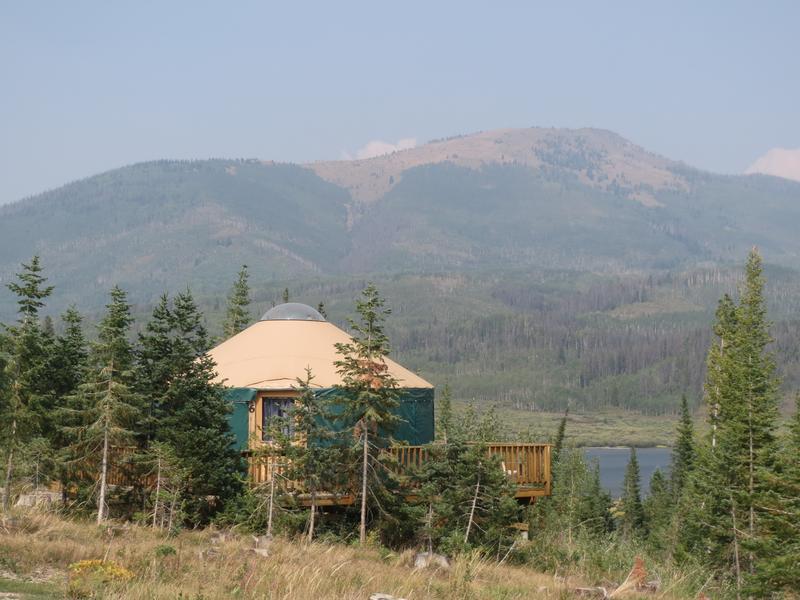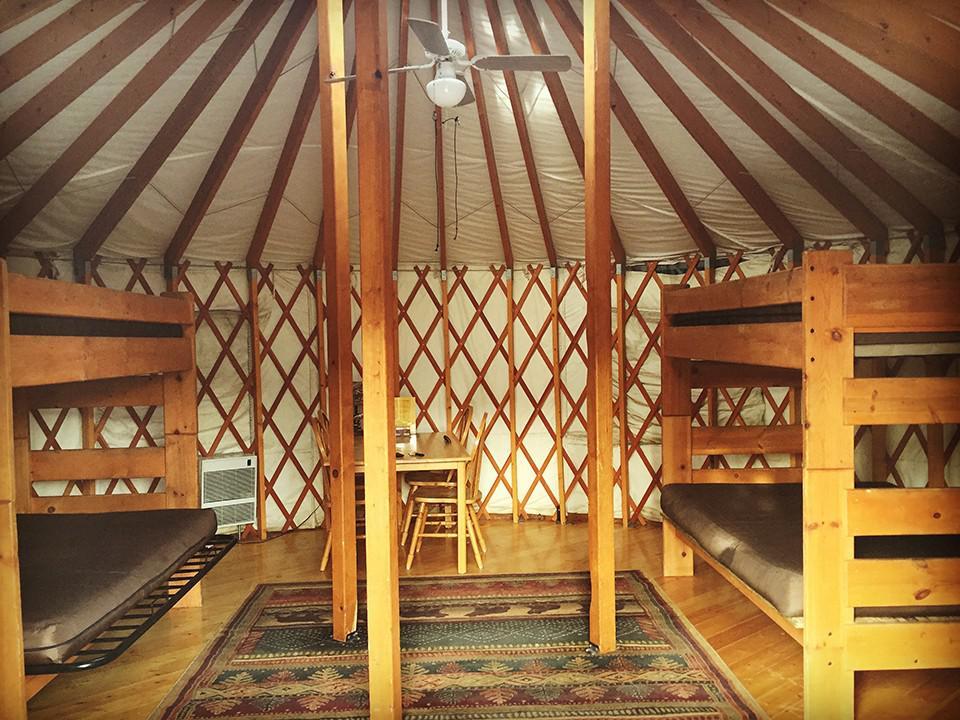The first image is the image on the left, the second image is the image on the right. Examine the images to the left and right. Is the description "Two green round houses have white roofs and sit on flat wooden platforms." accurate? Answer yes or no. No. 